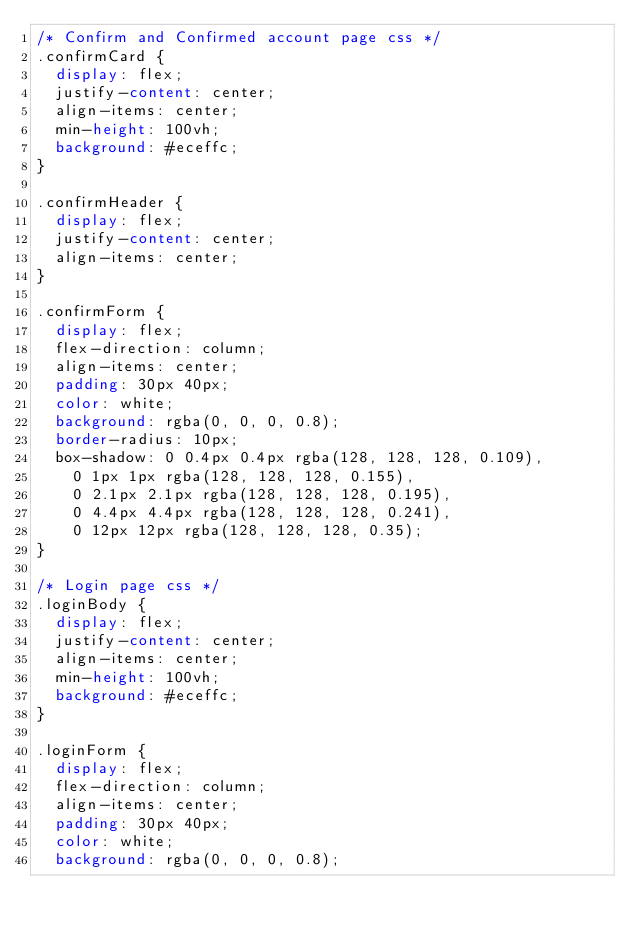Convert code to text. <code><loc_0><loc_0><loc_500><loc_500><_CSS_>/* Confirm and Confirmed account page css */
.confirmCard {
  display: flex;
  justify-content: center;
  align-items: center;
  min-height: 100vh;
  background: #eceffc;
}

.confirmHeader {
  display: flex;
  justify-content: center;
  align-items: center;
}

.confirmForm {
  display: flex;
  flex-direction: column;
  align-items: center;
  padding: 30px 40px;
  color: white;
  background: rgba(0, 0, 0, 0.8);
  border-radius: 10px;
  box-shadow: 0 0.4px 0.4px rgba(128, 128, 128, 0.109),
    0 1px 1px rgba(128, 128, 128, 0.155),
    0 2.1px 2.1px rgba(128, 128, 128, 0.195),
    0 4.4px 4.4px rgba(128, 128, 128, 0.241),
    0 12px 12px rgba(128, 128, 128, 0.35);
}

/* Login page css */
.loginBody {
  display: flex;
  justify-content: center;
  align-items: center;
  min-height: 100vh;
  background: #eceffc;
}

.loginForm {
  display: flex;
  flex-direction: column;
  align-items: center;
  padding: 30px 40px;
  color: white;
  background: rgba(0, 0, 0, 0.8);</code> 